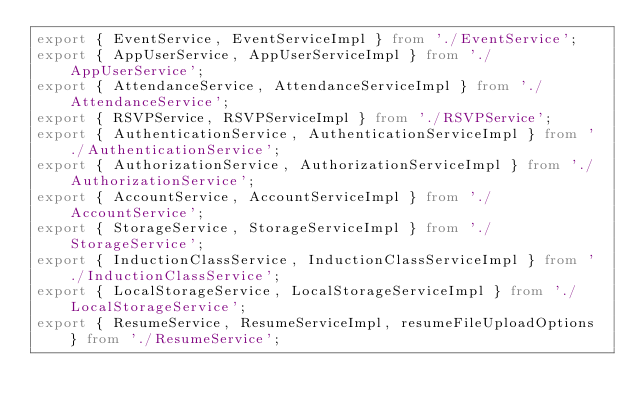<code> <loc_0><loc_0><loc_500><loc_500><_TypeScript_>export { EventService, EventServiceImpl } from './EventService';
export { AppUserService, AppUserServiceImpl } from './AppUserService';
export { AttendanceService, AttendanceServiceImpl } from './AttendanceService';
export { RSVPService, RSVPServiceImpl } from './RSVPService';
export { AuthenticationService, AuthenticationServiceImpl } from './AuthenticationService';
export { AuthorizationService, AuthorizationServiceImpl } from './AuthorizationService';
export { AccountService, AccountServiceImpl } from './AccountService';
export { StorageService, StorageServiceImpl } from './StorageService';
export { InductionClassService, InductionClassServiceImpl } from './InductionClassService';
export { LocalStorageService, LocalStorageServiceImpl } from './LocalStorageService';
export { ResumeService, ResumeServiceImpl, resumeFileUploadOptions } from './ResumeService';
</code> 